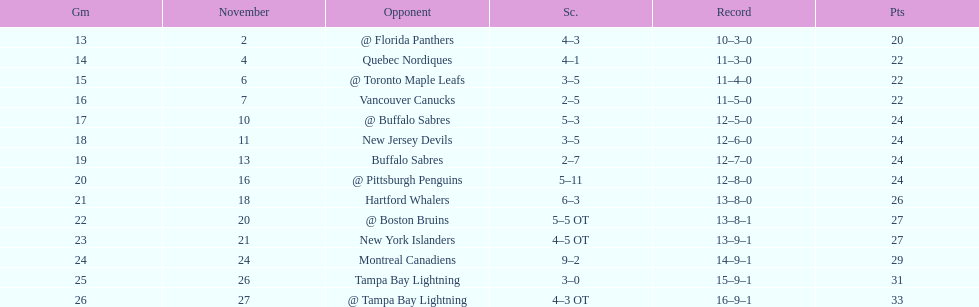Did the tampa bay lightning have the least amount of wins? Yes. 